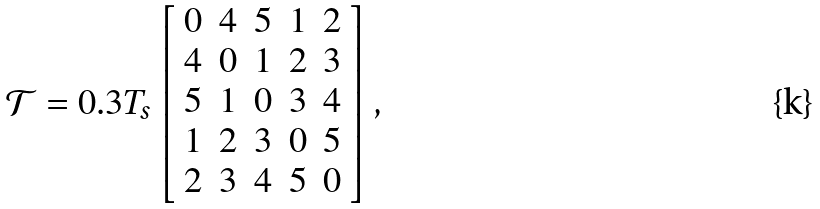Convert formula to latex. <formula><loc_0><loc_0><loc_500><loc_500>\mathcal { T } = 0 . 3 T _ { s } \left [ \begin{array} { c c c c c } 0 & 4 & 5 & 1 & 2 \\ 4 & 0 & 1 & 2 & 3 \\ 5 & 1 & 0 & 3 & 4 \\ 1 & 2 & 3 & 0 & 5 \\ 2 & 3 & 4 & 5 & 0 \\ \end{array} \right ] ,</formula> 